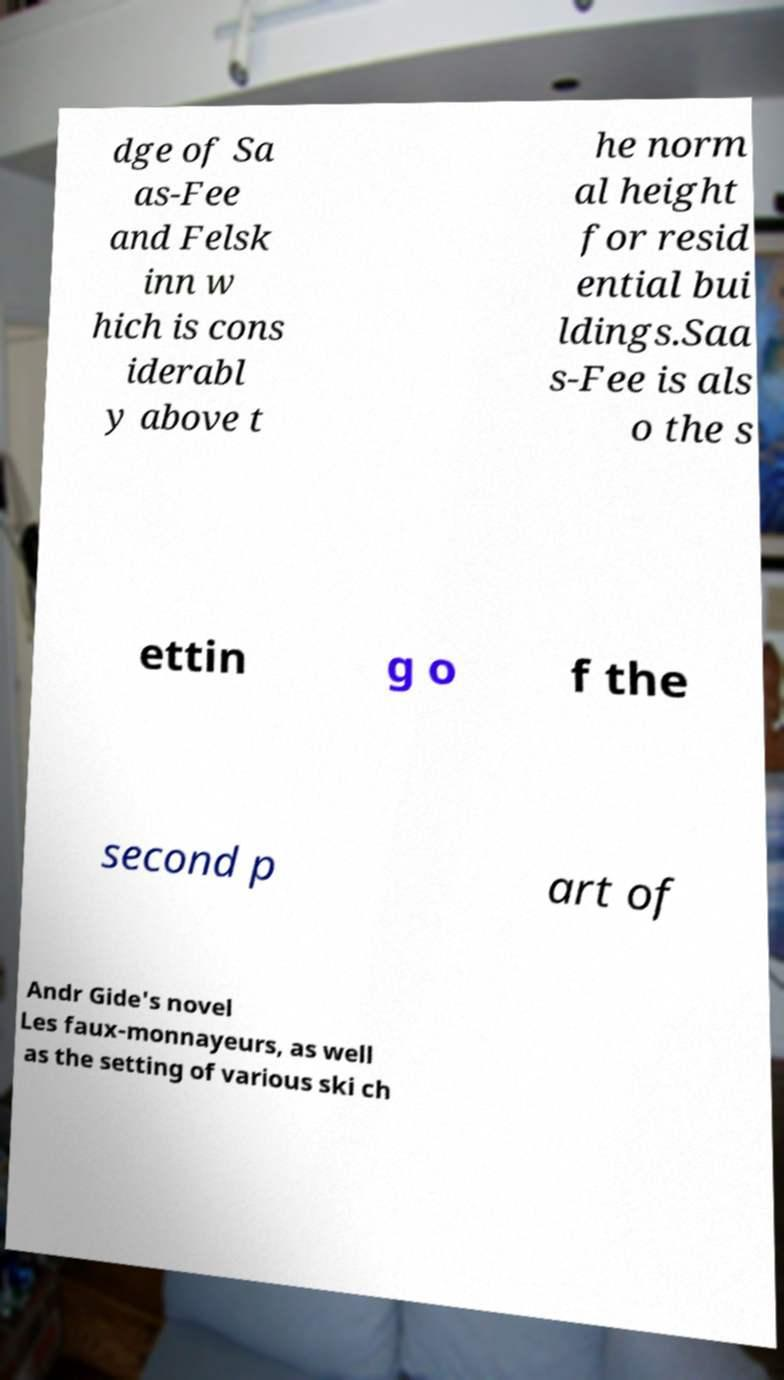I need the written content from this picture converted into text. Can you do that? dge of Sa as-Fee and Felsk inn w hich is cons iderabl y above t he norm al height for resid ential bui ldings.Saa s-Fee is als o the s ettin g o f the second p art of Andr Gide's novel Les faux-monnayeurs, as well as the setting of various ski ch 